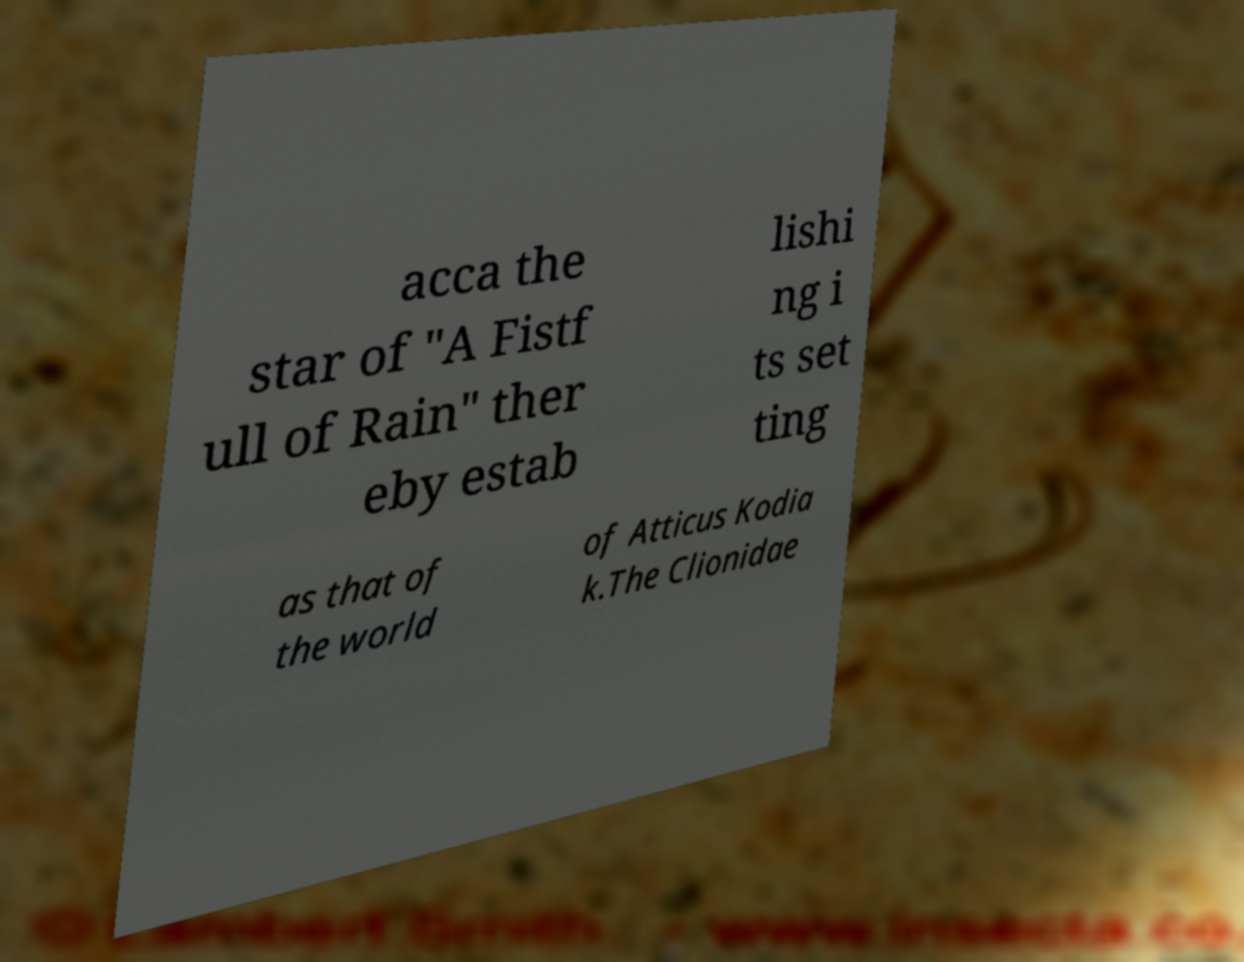Please identify and transcribe the text found in this image. acca the star of "A Fistf ull of Rain" ther eby estab lishi ng i ts set ting as that of the world of Atticus Kodia k.The Clionidae 